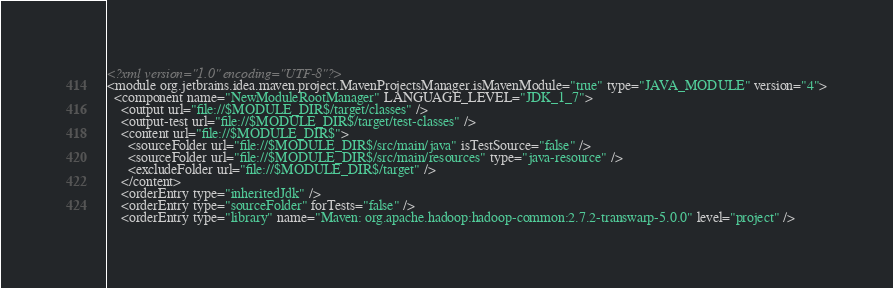<code> <loc_0><loc_0><loc_500><loc_500><_XML_><?xml version="1.0" encoding="UTF-8"?>
<module org.jetbrains.idea.maven.project.MavenProjectsManager.isMavenModule="true" type="JAVA_MODULE" version="4">
  <component name="NewModuleRootManager" LANGUAGE_LEVEL="JDK_1_7">
    <output url="file://$MODULE_DIR$/target/classes" />
    <output-test url="file://$MODULE_DIR$/target/test-classes" />
    <content url="file://$MODULE_DIR$">
      <sourceFolder url="file://$MODULE_DIR$/src/main/java" isTestSource="false" />
      <sourceFolder url="file://$MODULE_DIR$/src/main/resources" type="java-resource" />
      <excludeFolder url="file://$MODULE_DIR$/target" />
    </content>
    <orderEntry type="inheritedJdk" />
    <orderEntry type="sourceFolder" forTests="false" />
    <orderEntry type="library" name="Maven: org.apache.hadoop:hadoop-common:2.7.2-transwarp-5.0.0" level="project" /></code> 